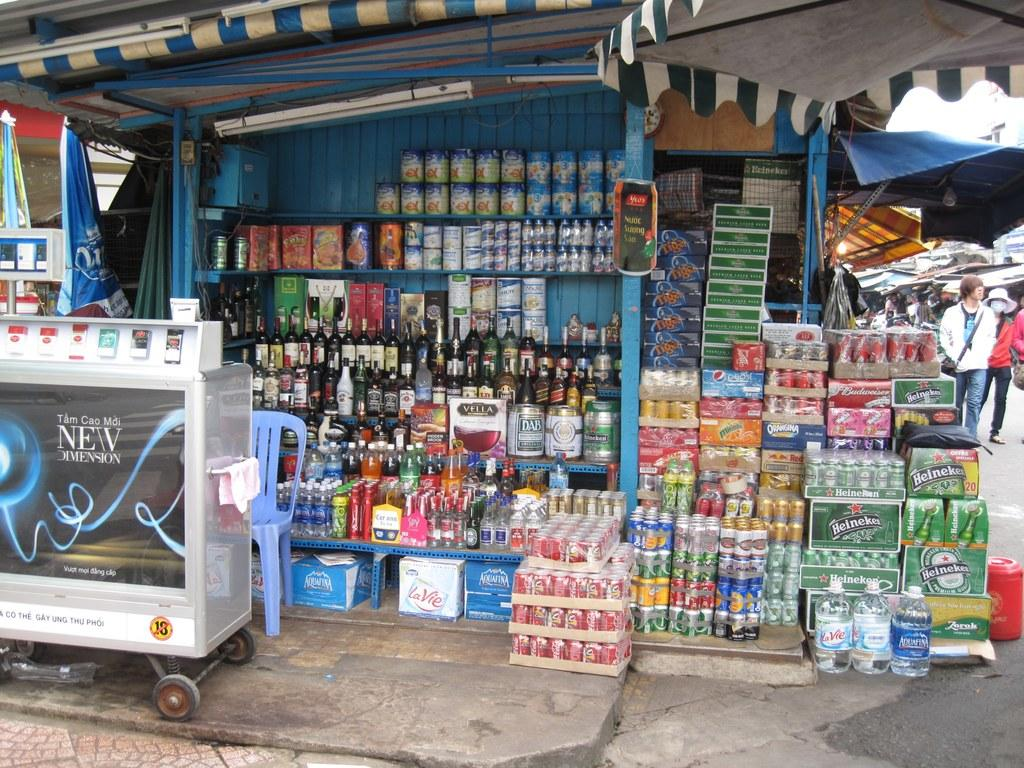<image>
Describe the image concisely. an open store front with liquor and various canned goods with an ad for NEW DIMENSION 